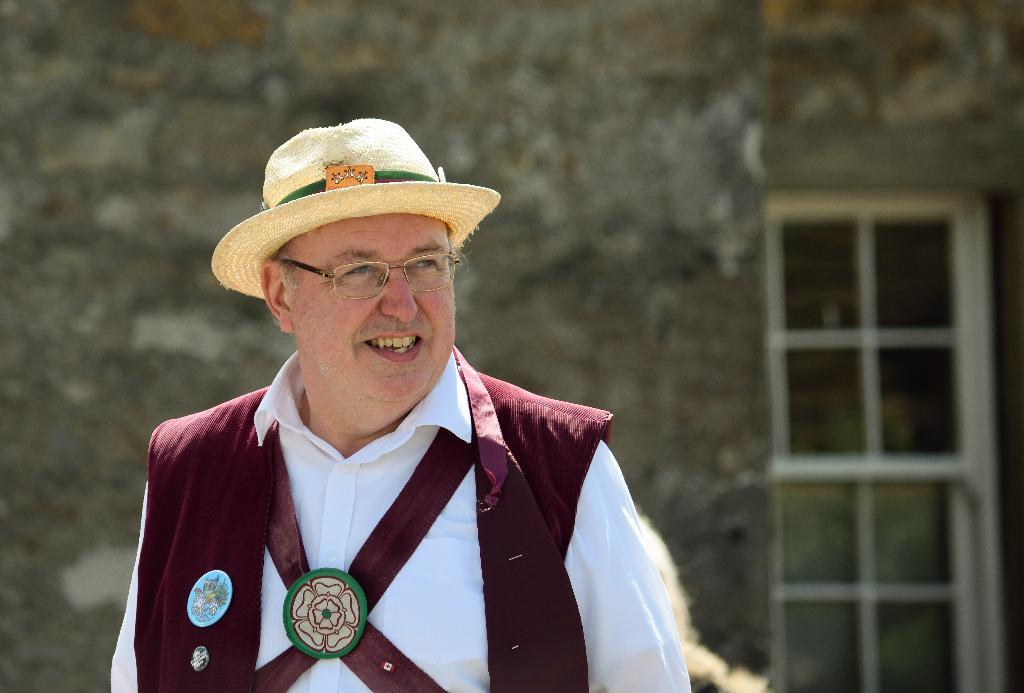What is the main subject in the foreground of the image? There is a person in the foreground of the image. What accessories is the person wearing? The person is wearing a hat and spectacles. What can be seen in the background of the image? There is a wall and a window in the background of the image. What type of cherries can be seen growing on the wall in the image? There are no cherries present in the image; the background features a wall and a window, but no plants or fruits are visible. 